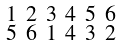<formula> <loc_0><loc_0><loc_500><loc_500>\begin{smallmatrix} 1 & 2 & 3 & 4 & 5 & 6 \\ 5 & 6 & 1 & 4 & 3 & 2 \end{smallmatrix}</formula> 